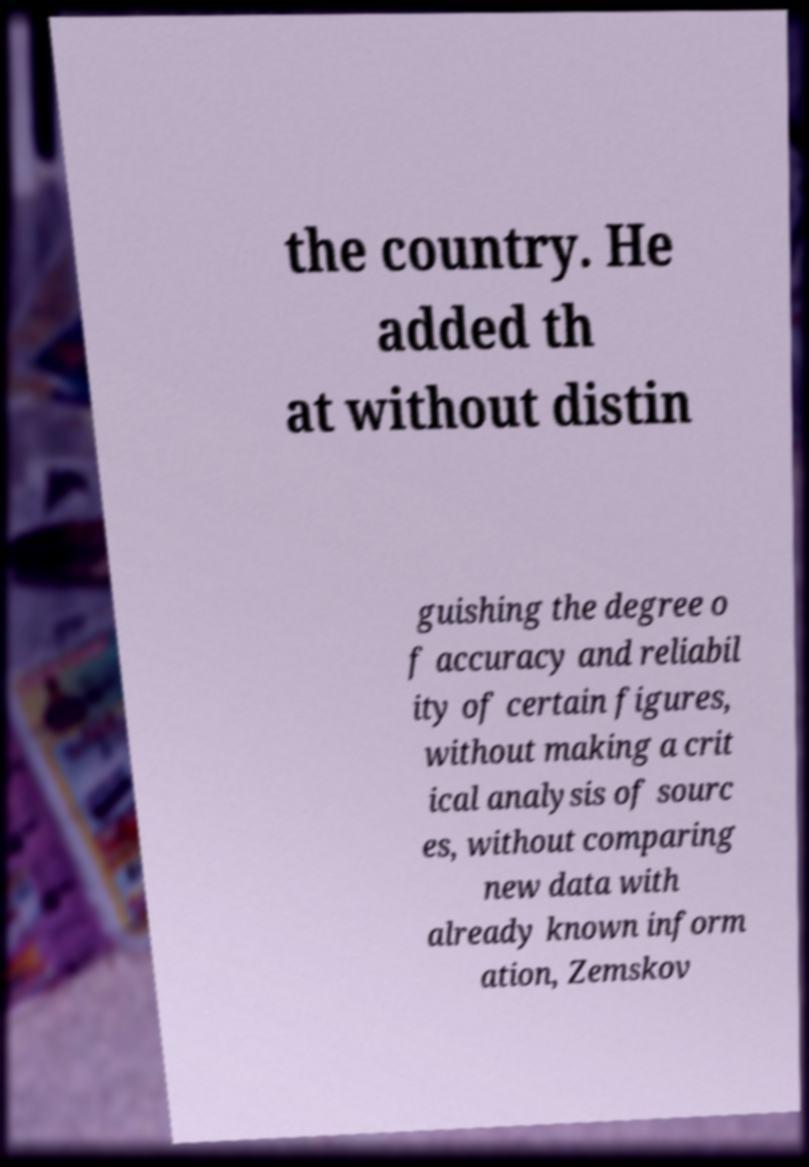There's text embedded in this image that I need extracted. Can you transcribe it verbatim? the country. He added th at without distin guishing the degree o f accuracy and reliabil ity of certain figures, without making a crit ical analysis of sourc es, without comparing new data with already known inform ation, Zemskov 